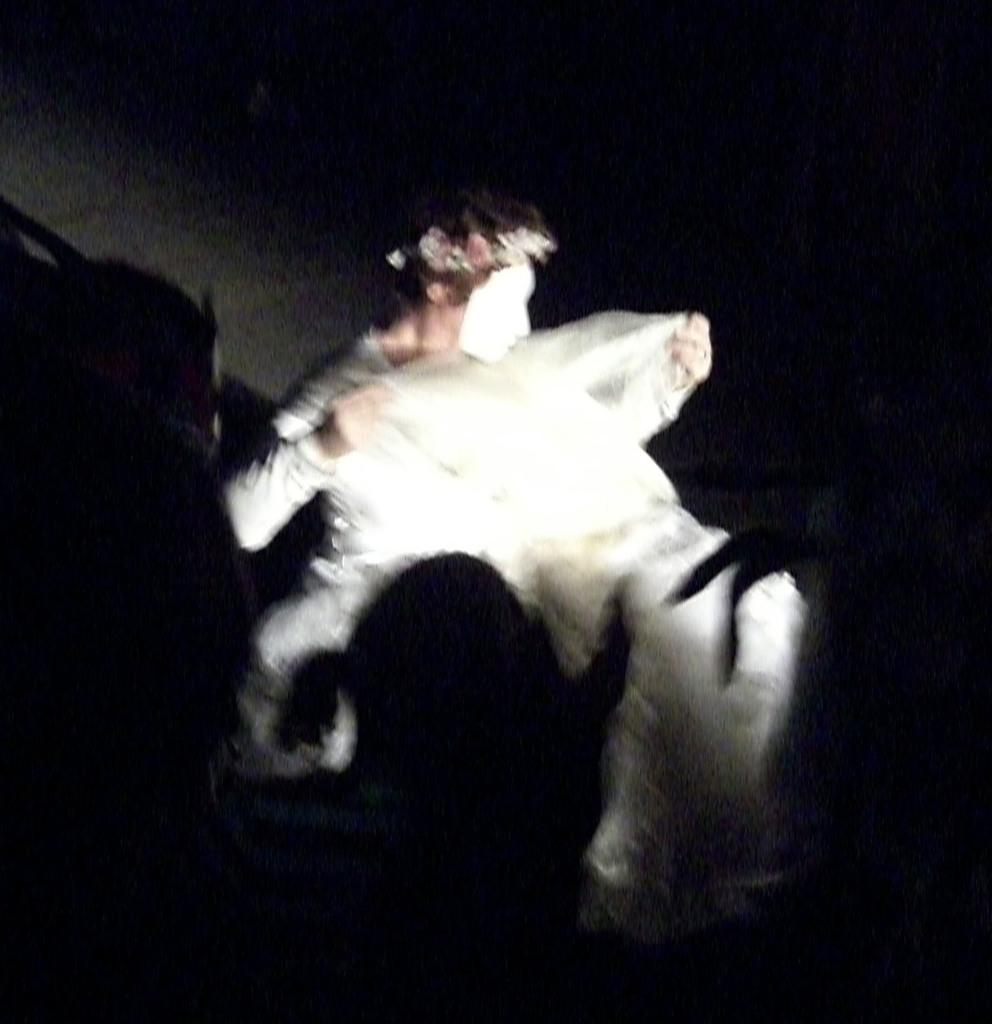What can be seen in the image related to a person? There is a person in the image. What is the person wearing on their face? The person is wearing a mask on their face. What object does the person appear to be holding? The person appears to be holding a white cloth. Can you describe any other people visible in the image? There are shadows of persons visible at the bottom of the image. What time does the clock show in the image? There is no clock present in the image. What type of lamp can be seen on the side of the person? There is no lamp visible in the image. 